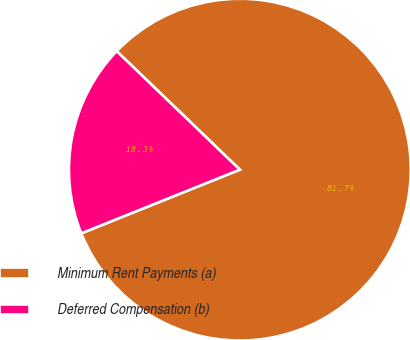Convert chart. <chart><loc_0><loc_0><loc_500><loc_500><pie_chart><fcel>Minimum Rent Payments (a)<fcel>Deferred Compensation (b)<nl><fcel>81.73%<fcel>18.27%<nl></chart> 